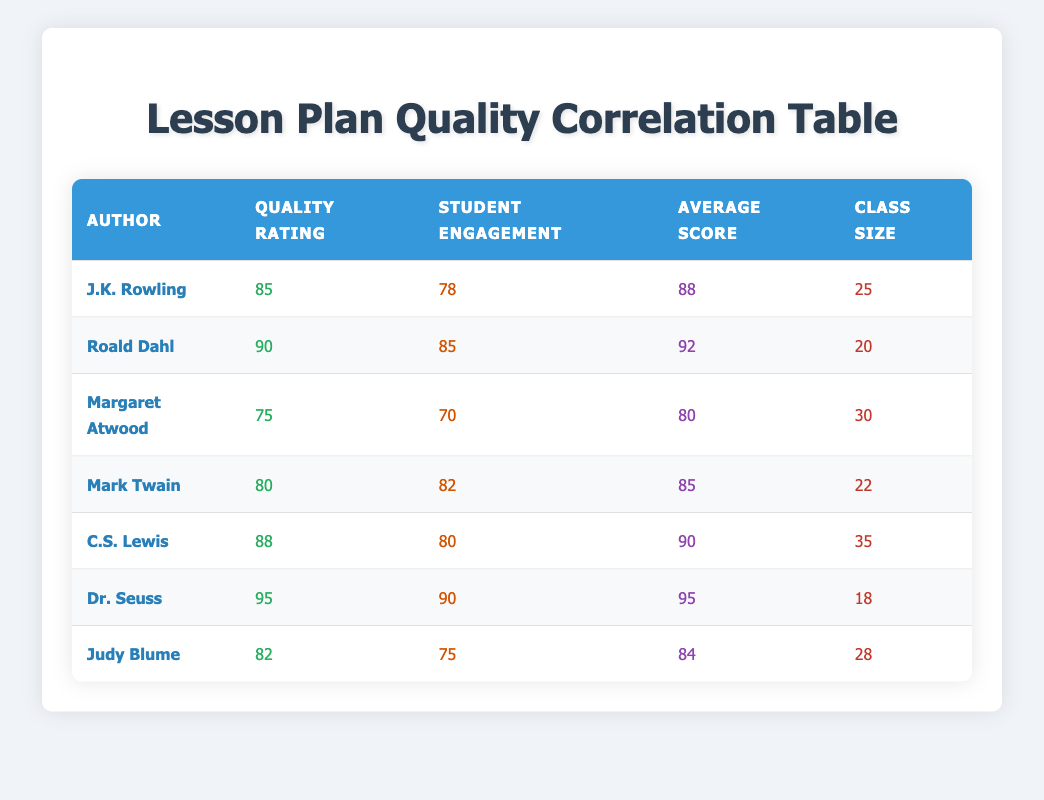What is the quality rating of Dr. Seuss's lesson plan? From the table, we can directly find the row for Dr. Seuss, which shows a quality rating of 95.
Answer: 95 Which author has the highest average score? By examining the average scores for each author, Dr. Seuss has an average score of 95, which is higher than all others.
Answer: Dr. Seuss What is the average quality rating across all lesson plans? To find the average, sum all quality ratings: (85 + 90 + 75 + 80 + 88 + 95 + 82) = 505. There are 7 lesson plans, so the average is 505/7 ≈ 72.14.
Answer: 72.14 Is there an author whose student engagement is higher than their quality rating? Looking at the table, Margaret Atwood has a quality rating of 75 and student engagement of 70, which is not higher, but Judy Blume has a quality rating of 82 and student engagement of 75. Thus there is no author who meets this criteria.
Answer: No What is the class size of the author with the second-highest student engagement? By inspecting the student engagement values, Dr. Seuss has the highest engagement at 90, and Roald Dahl has the second-highest at 85. Roald Dahl's class size is 20 as per the table.
Answer: 20 How much higher is the average score of J.K. Rowling's lesson plan compared to Margaret Atwood's lesson plan? J.K. Rowling's average score is 88 and Margaret Atwood's is 80. The difference is 88 - 80 = 8.
Answer: 8 What is the total of the class sizes for all authors? To calculate the total class size, add all individual class sizes: (25 + 20 + 30 + 22 + 35 + 18 + 28) = 208.
Answer: 208 Do any authors have the same quality rating? There are no repeated quality ratings among the authors listed in the table. All authors have unique quality ratings.
Answer: No What is the relationship between quality rating and average scores in the table? By examining the data, generally as the quality rating increases, the average score also increases, indicating a positive correlation. Specifically, Dr. Seuss has the highest ratings in both categories, demonstrating this trend.
Answer: Positive correlation 